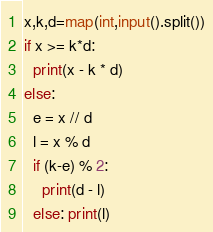Convert code to text. <code><loc_0><loc_0><loc_500><loc_500><_Cython_>x,k,d=map(int,input().split())
if x >= k*d:
  print(x - k * d)
else:
  e = x // d
  l = x % d
  if (k-e) % 2:
    print(d - l)
  else: print(l)</code> 